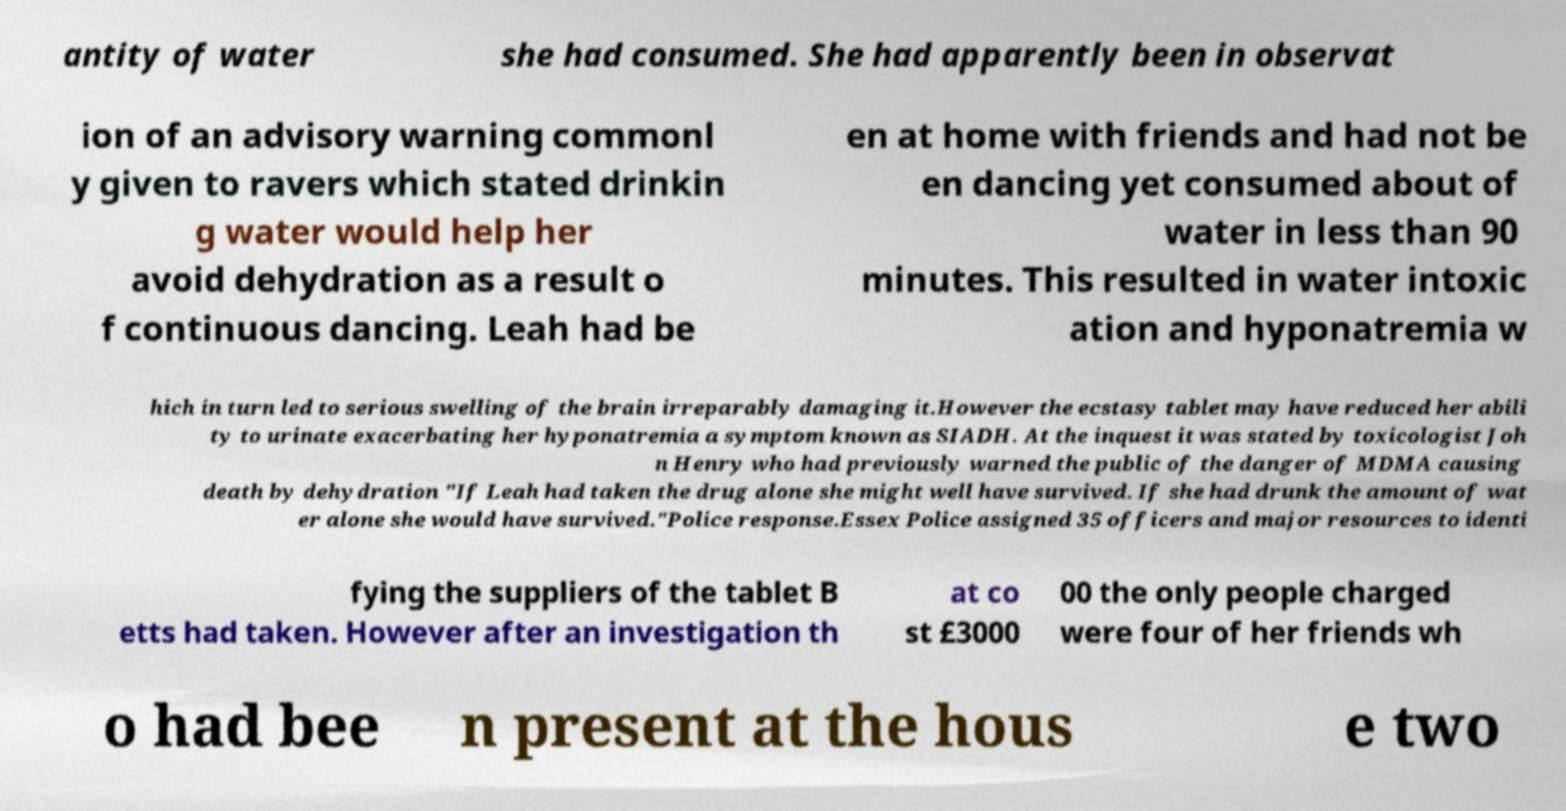There's text embedded in this image that I need extracted. Can you transcribe it verbatim? antity of water she had consumed. She had apparently been in observat ion of an advisory warning commonl y given to ravers which stated drinkin g water would help her avoid dehydration as a result o f continuous dancing. Leah had be en at home with friends and had not be en dancing yet consumed about of water in less than 90 minutes. This resulted in water intoxic ation and hyponatremia w hich in turn led to serious swelling of the brain irreparably damaging it.However the ecstasy tablet may have reduced her abili ty to urinate exacerbating her hyponatremia a symptom known as SIADH. At the inquest it was stated by toxicologist Joh n Henry who had previously warned the public of the danger of MDMA causing death by dehydration "If Leah had taken the drug alone she might well have survived. If she had drunk the amount of wat er alone she would have survived."Police response.Essex Police assigned 35 officers and major resources to identi fying the suppliers of the tablet B etts had taken. However after an investigation th at co st £3000 00 the only people charged were four of her friends wh o had bee n present at the hous e two 